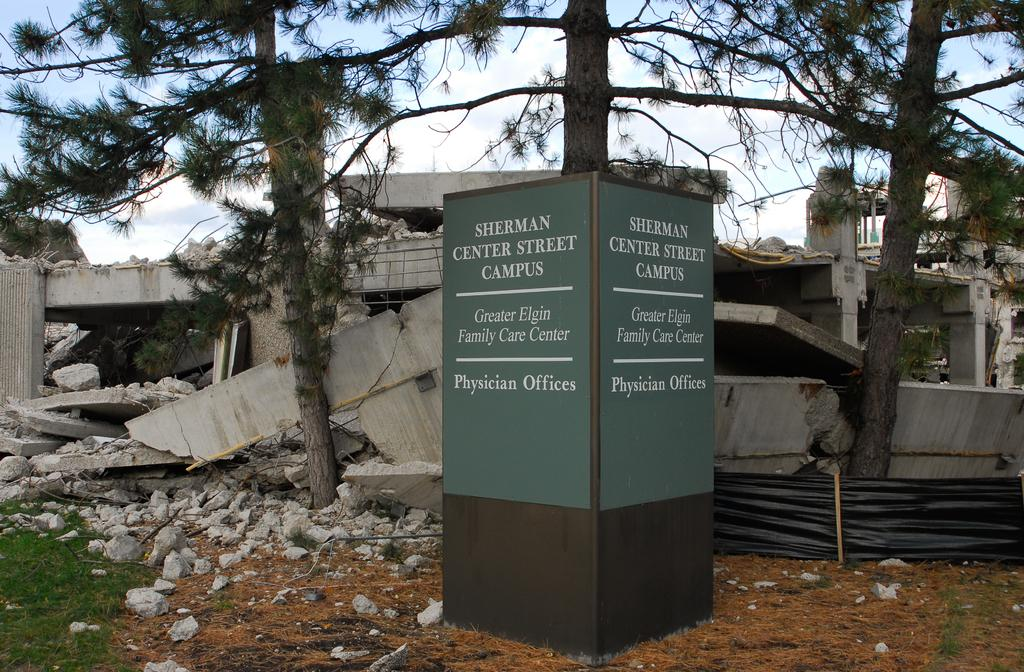What type of structure is present in the image? There is an informational pillar in the image. What type of vegetation can be seen in the image? There is grass visible in the image. What type of man-made structure is damaged in the image? There is a destroyed building in the image. What type of natural structures are present in the image? There are trees in the image. What type of ground surface is present in the image? Soil is present in the image. What part of the natural environment is visible in the image? The sky is visible in the image. What type of weather can be inferred from the image? Clouds are present in the sky, suggesting a partly cloudy day. What type of toy can be seen playing with the destroyed building in the image? There is no toy present in the image, and the destroyed building is not depicted as playing with anything. 